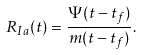<formula> <loc_0><loc_0><loc_500><loc_500>R _ { I a } ( t ) = \frac { \Psi ( t - t _ { f } ) } { m ( t - t _ { f } ) } .</formula> 